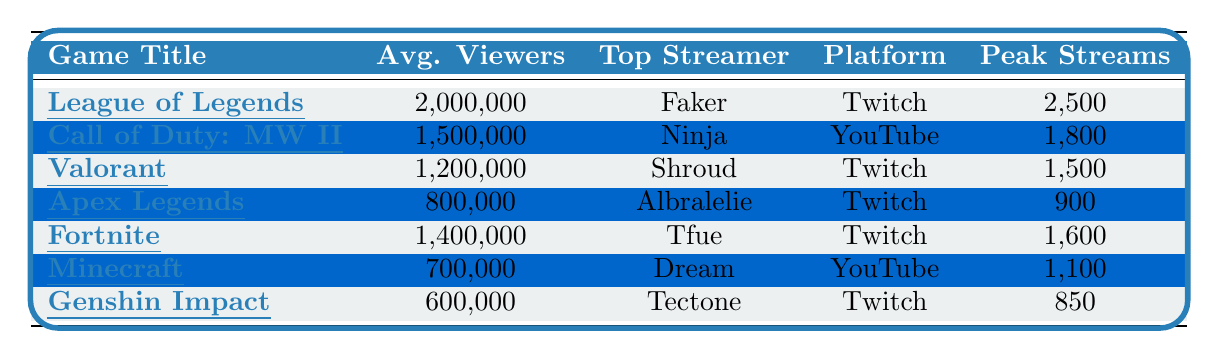What is the average number of viewers for League of Legends? The table shows that League of Legends has an average of 2,000,000 viewers.
Answer: 2,000,000 Who is the top streamer for Fortnite? The table indicates that the top streamer for Fortnite is Tfue.
Answer: Tfue Which game has the highest peak stream count? By comparing the peak stream counts, League of Legends has the highest at 2,500 streams.
Answer: League of Legends Is Apex Legends more popular than Minecraft based on average viewers? Apex Legends has 800,000 average viewers while Minecraft has 700,000. Therefore, Apex Legends is more popular as it has a higher average viewer count.
Answer: Yes What is the total average viewers for Call of Duty: Modern Warfare II and Valorant combined? The average viewers for Call of Duty: Modern Warfare II is 1,500,000 and for Valorant it is 1,200,000. Adding these gives 1,500,000 + 1,200,000 = 2,700,000.
Answer: 2,700,000 Which platform has the most games represented in the table? By counting the platforms listed, Twitch has League of Legends, Valorant, Apex Legends, and Fortnite, totaling four games. YouTube has Call of Duty: Modern Warfare II and Minecraft, totaling two games. Therefore, Twitch represents more games.
Answer: Twitch What is the difference in average viewers between Genshin Impact and League of Legends? Genshin Impact has 600,000 average viewers and League of Legends has 2,000,000. The difference is calculated as 2,000,000 - 600,000 = 1,400,000 viewers.
Answer: 1,400,000 Is there a game that has both a top streamer on Twitch and the highest average viewers? The highest average viewers belongs to League of Legends with 2,000,000 and its top streamer is Faker, who streams on Twitch.
Answer: Yes What is the lowest peak stream count among the games listed? The table shows that the lowest peak stream count is for Genshin Impact with 850 streams.
Answer: 850 Which game had notable events in 2023 related to a world championship? League of Legends had notable events mentioning the "2023 World Championship".
Answer: League of Legends 